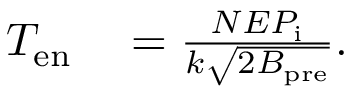<formula> <loc_0><loc_0><loc_500><loc_500>\begin{array} { r l } { T _ { e n } } & = \frac { N E P _ { i } } { k \sqrt { 2 B _ { p r e } } } . } \end{array}</formula> 